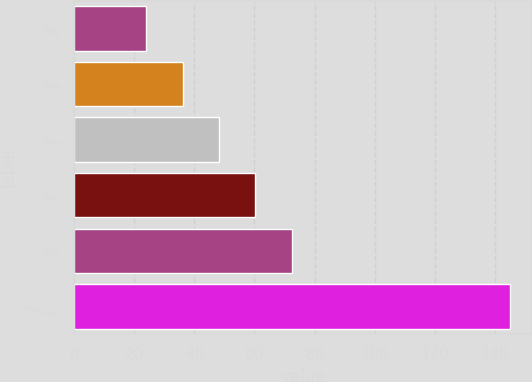<chart> <loc_0><loc_0><loc_500><loc_500><bar_chart><fcel>2018<fcel>2019<fcel>2020<fcel>2021<fcel>2022<fcel>2023-2027<nl><fcel>24<fcel>36.1<fcel>48.2<fcel>60.3<fcel>72.4<fcel>145<nl></chart> 